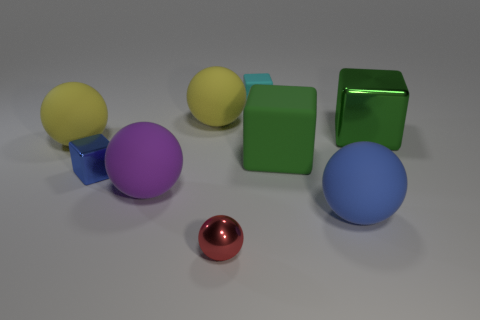Is the color of the large shiny block the same as the small sphere?
Offer a very short reply. No. What number of things are either yellow things or blocks that are to the right of the red object?
Make the answer very short. 5. Are there an equal number of green blocks that are to the left of the big purple sphere and big blue matte balls?
Offer a terse response. No. What is the shape of the large thing that is the same material as the tiny red ball?
Provide a short and direct response. Cube. Are there any small metal blocks of the same color as the large metal thing?
Your answer should be very brief. No. How many shiny things are green objects or small balls?
Keep it short and to the point. 2. How many big objects are in front of the blue object to the left of the big blue rubber object?
Provide a succinct answer. 2. How many red balls are made of the same material as the blue ball?
Offer a very short reply. 0. How many tiny objects are either purple matte things or blocks?
Keep it short and to the point. 2. What shape is the tiny object that is on the right side of the large purple ball and behind the large purple object?
Keep it short and to the point. Cube. 